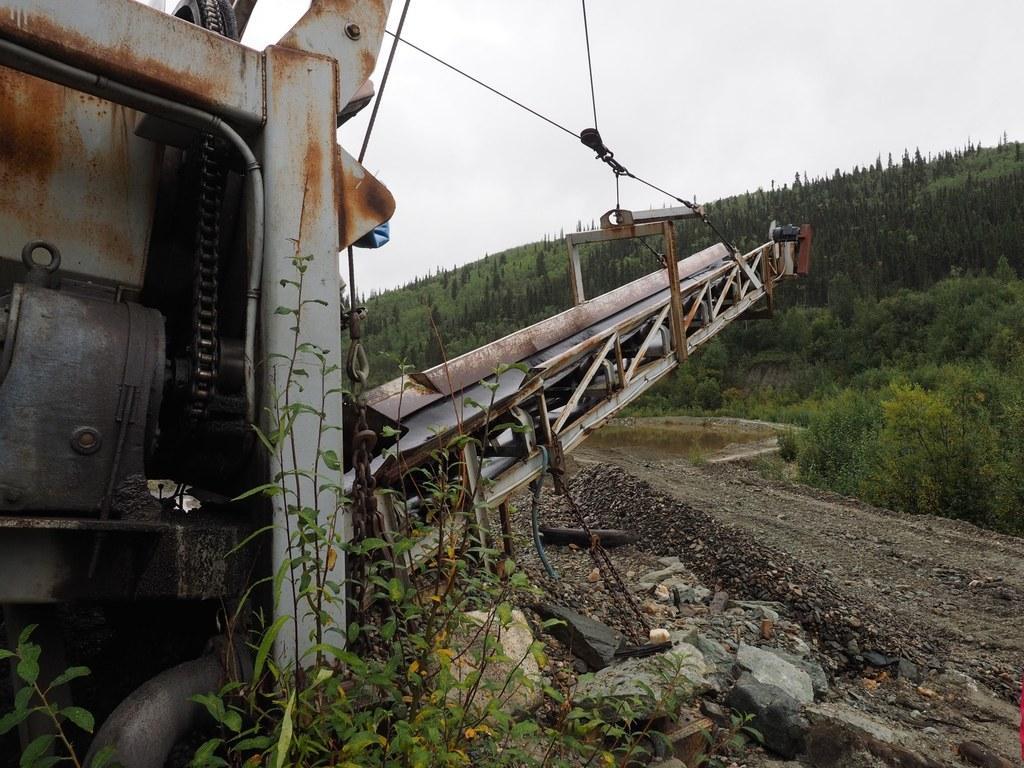Could you give a brief overview of what you see in this image? On the left side of the image we can see one vehicle, wires, one pole type structure, plants, stones and a few other objects. In the background we can see the sky, clouds, trees etc. 